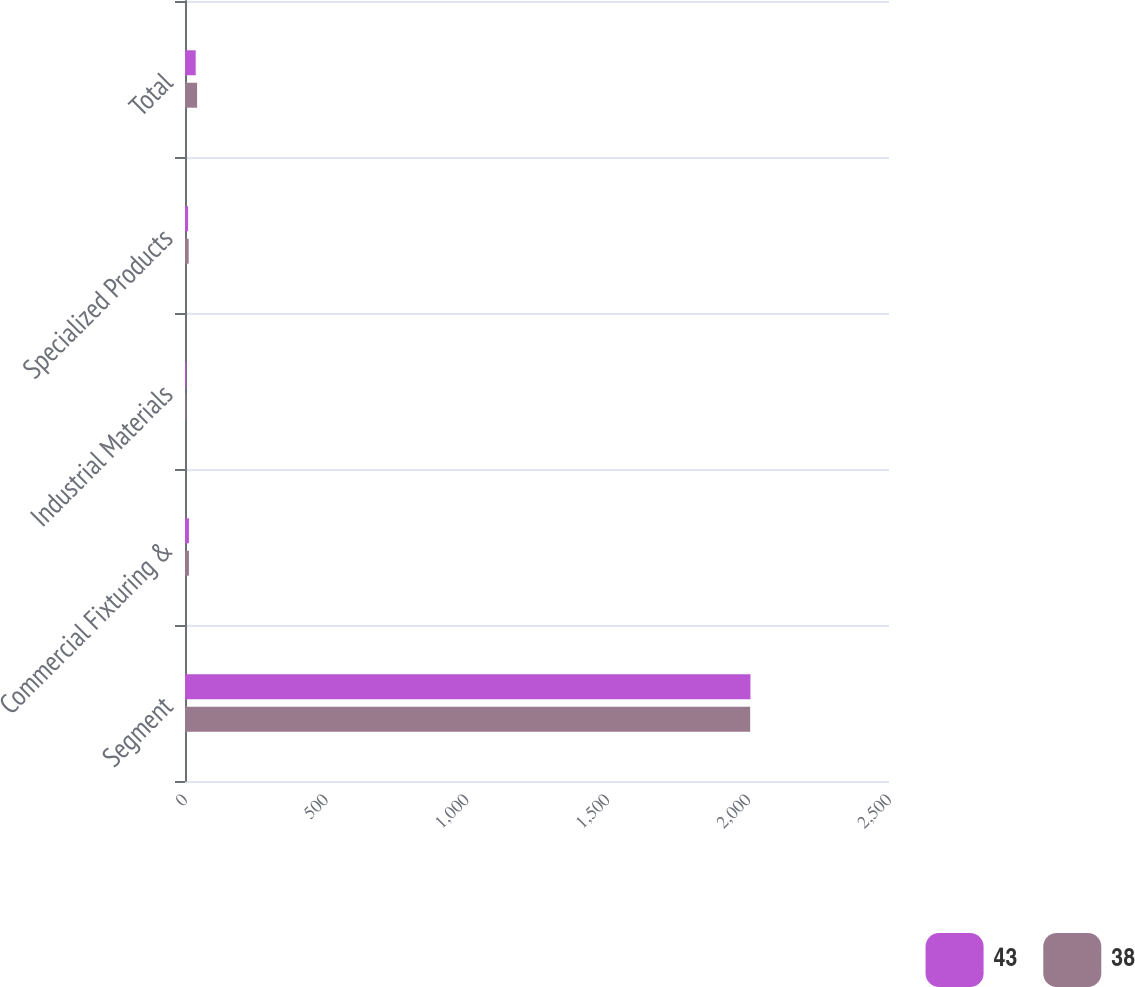<chart> <loc_0><loc_0><loc_500><loc_500><stacked_bar_chart><ecel><fcel>Segment<fcel>Commercial Fixturing &<fcel>Industrial Materials<fcel>Specialized Products<fcel>Total<nl><fcel>43<fcel>2008<fcel>14<fcel>4<fcel>11<fcel>38<nl><fcel>38<fcel>2007<fcel>14<fcel>3<fcel>13<fcel>43<nl></chart> 